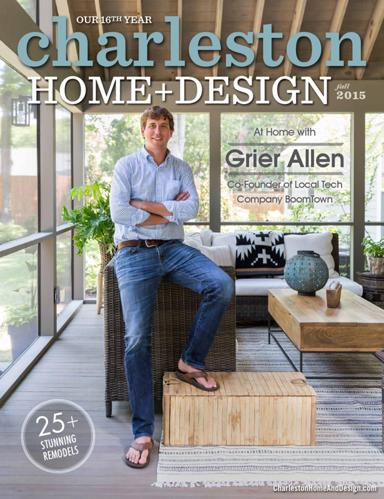Can you tell me more about the design style of the room featured on the cover? The room on the cover features a contemporary design style with elements like a spacious layout, clean lines, and a neutral color palette. It perfectly blends modern furniture with rustic accents, creating a cozy yet elegant atmosphere. 